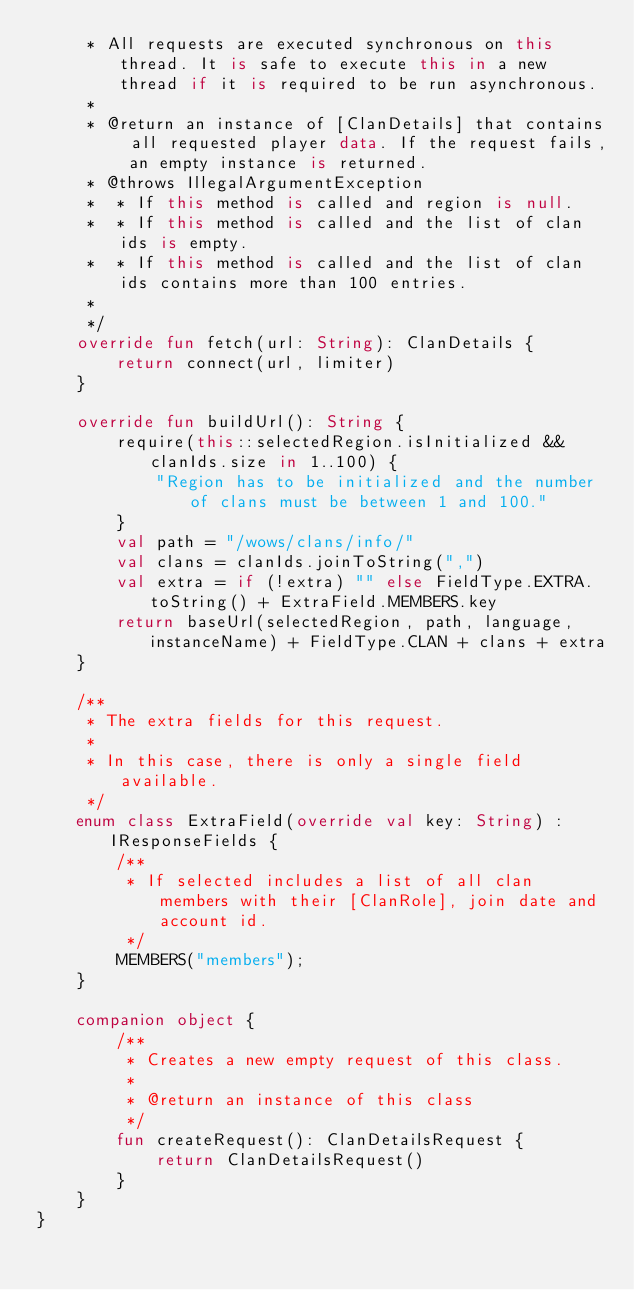Convert code to text. <code><loc_0><loc_0><loc_500><loc_500><_Kotlin_>     * All requests are executed synchronous on this thread. It is safe to execute this in a new thread if it is required to be run asynchronous.
     *
     * @return an instance of [ClanDetails] that contains all requested player data. If the request fails, an empty instance is returned.
     * @throws IllegalArgumentException
     *  * If this method is called and region is null.
     *  * If this method is called and the list of clan ids is empty.
     *  * If this method is called and the list of clan ids contains more than 100 entries.
     *
     */
    override fun fetch(url: String): ClanDetails {
        return connect(url, limiter)
    }

    override fun buildUrl(): String {
        require(this::selectedRegion.isInitialized && clanIds.size in 1..100) {
            "Region has to be initialized and the number of clans must be between 1 and 100."
        }
        val path = "/wows/clans/info/"
        val clans = clanIds.joinToString(",")
        val extra = if (!extra) "" else FieldType.EXTRA.toString() + ExtraField.MEMBERS.key
        return baseUrl(selectedRegion, path, language, instanceName) + FieldType.CLAN + clans + extra
    }

    /**
     * The extra fields for this request.
     *
     * In this case, there is only a single field available.
     */
    enum class ExtraField(override val key: String) : IResponseFields {
        /**
         * If selected includes a list of all clan members with their [ClanRole], join date and account id.
         */
        MEMBERS("members");
    }

    companion object {
        /**
         * Creates a new empty request of this class.
         *
         * @return an instance of this class
         */
        fun createRequest(): ClanDetailsRequest {
            return ClanDetailsRequest()
        }
    }
}</code> 